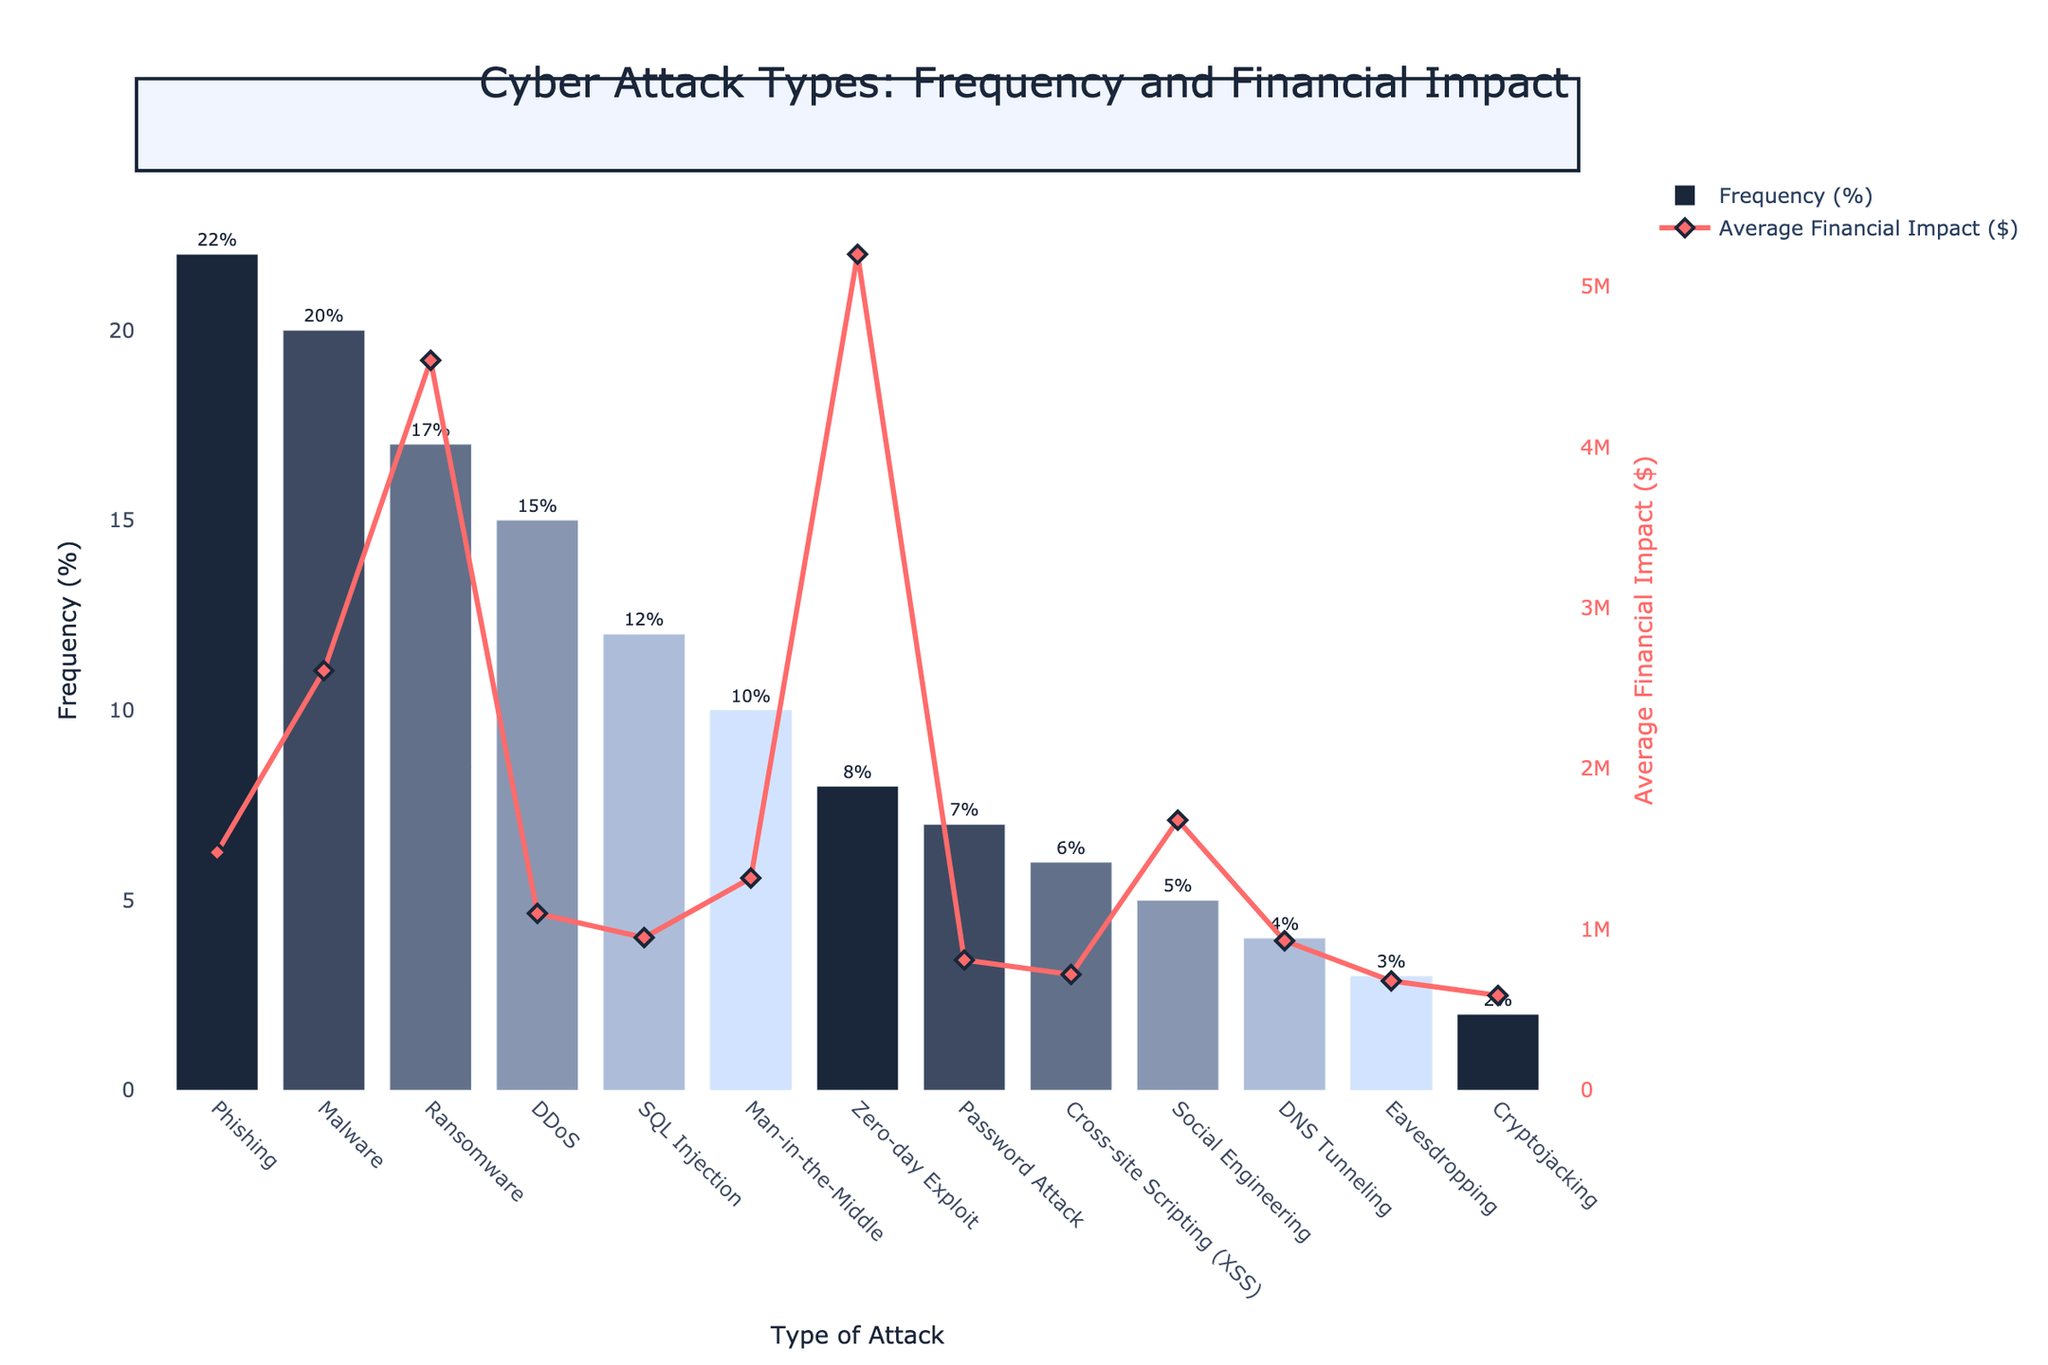Which type of attack is the most common? The frequency bars indicate that Phishing has the highest frequency at 22%.
Answer: Phishing How does the average financial impact of Malware compare to that of Phishing? The line graph shows Malware's average financial impact is $2,610,000, which is higher than Phishing's $1,480,000.
Answer: Malware has a higher impact What is the sum of the average financial impacts of Ransomware and Zero-day Exploit? Ransomware's impact is $4,540,000 and Zero-day Exploit's impact is $5,200,000. Adding them together, $4,540,000 + $5,200,000 = $9,740,000.
Answer: $9,740,000 Which attack type has the lowest frequency, and what is its financial impact? Cryptojacking has the lowest frequency at 2%, with an average financial impact of $590,000.
Answer: Cryptojacking, $590,000 Are there any types of attacks with the same frequency percentage, and if so, which ones? The frequency percentages are unique across all attack types, so no duplicates exist.
Answer: No Which attack has the second-highest average financial impact? Zero-day Exploit has the second-highest average financial impact at $5,200,000, as shown by the outlier points on the financial impact line.
Answer: Zero-day Exploit Compare the frequency of Man-in-the-Middle attacks to Password Attacks. Man-in-the-Middle attacks have a frequency of 10%, which is higher than Password Attacks at 7%.
Answer: Man-in-the-Middle higher How much higher is the financial impact of the attack with the highest impact compared to the lowest impact? Zero-day Exploit has the highest impact at $5,200,000, and Cryptojacking the lowest at $590,000. The difference is $5,200,000 - $590,000 = $4,610,000.
Answer: $4,610,000 What is the average frequency of DDoS and Man-in-the-Middle attacks combined? The frequencies are 15% for DDoS and 10% for Man-in-the-Middle. The average is (15% + 10%) / 2 = 12.5%.
Answer: 12.5% Which attack type has both relatively high frequency and high financial impact? Ransomware has a notable combination of high frequency (17%) and a high financial impact ($4,540,000).
Answer: Ransomware 